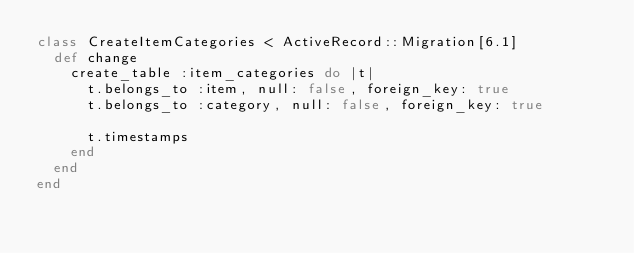Convert code to text. <code><loc_0><loc_0><loc_500><loc_500><_Ruby_>class CreateItemCategories < ActiveRecord::Migration[6.1]
  def change
    create_table :item_categories do |t|
      t.belongs_to :item, null: false, foreign_key: true
      t.belongs_to :category, null: false, foreign_key: true

      t.timestamps
    end
  end
end
</code> 